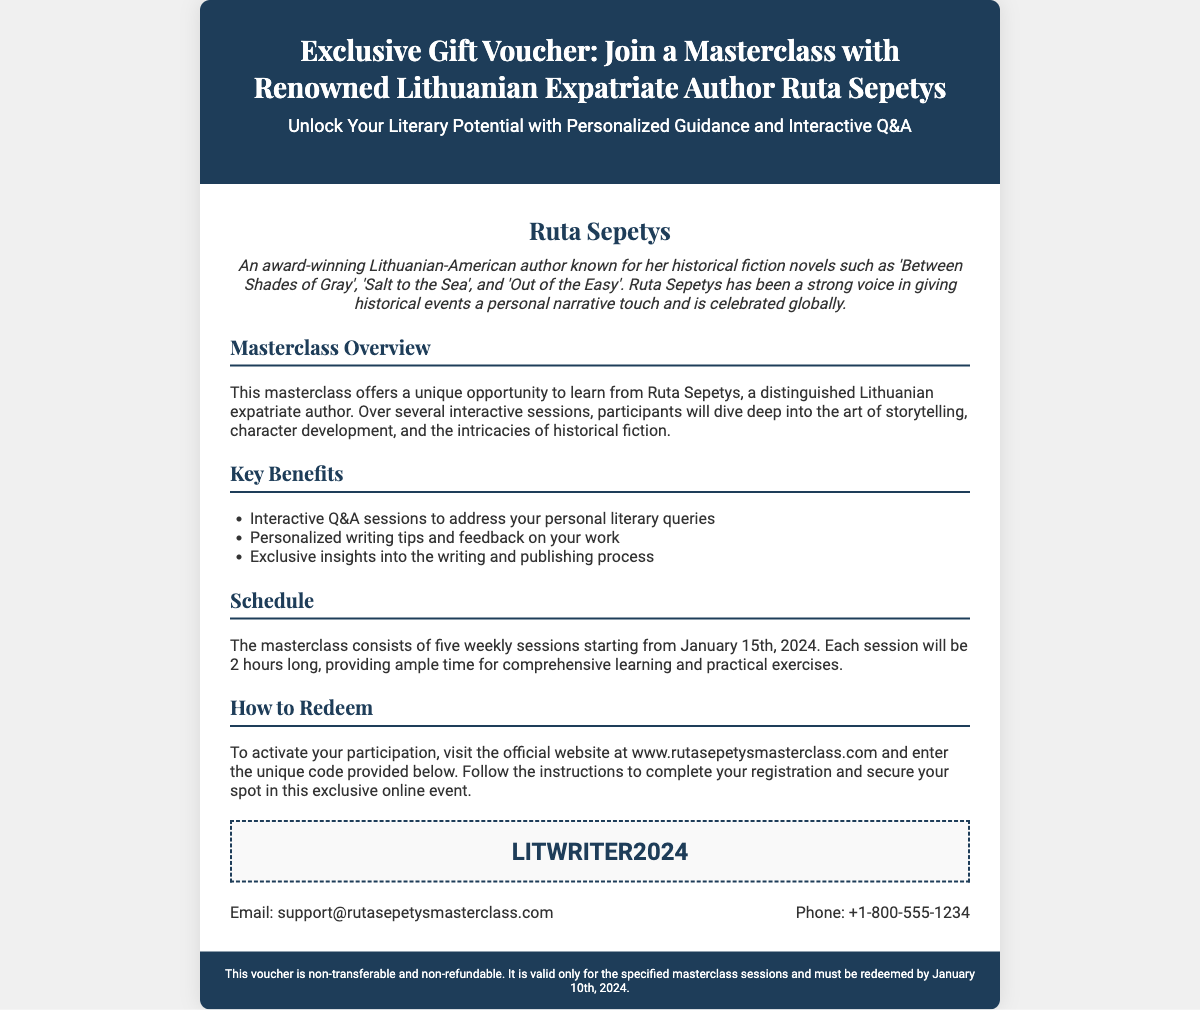What is the name of the author featured in the masterclass? The document prominently mentions the author who is hosting the masterclass, which is Ruta Sepetys.
Answer: Ruta Sepetys What is the unique code to redeem the voucher? The voucher specifies a unique code that must be entered on the official website, which is highlighted in a specific section.
Answer: LITWRITER2024 How many sessions does the masterclass consist of? The overview section details the structure of the masterclass in terms of sessions, stating that there are five weekly sessions.
Answer: five What is the starting date of the masterclass? The schedule section indicates when the masterclass begins, clearly mentioning January 15th, 2024.
Answer: January 15th, 2024 What is one key benefit of attending the masterclass? The key benefits section lists significant advantages of participating in the masterclass, such as Q&A sessions.
Answer: Interactive Q&A sessions What is the length of each session? The schedule section informs about the duration for each of the sessions, highlighting it as 2 hours.
Answer: 2 hours What is the registration deadline for the masterclass? The footer indicates the date by which the voucher must be redeemed in order to participate in the masterclass.
Answer: January 10th, 2024 Is the voucher transferable? The document includes specific conditions about the voucher’s validity, including its transferability.
Answer: non-transferable What type of author is Ruta Sepetys described as? The author background section describes her work and influence, specifying her genre as historical fiction.
Answer: historical fiction 